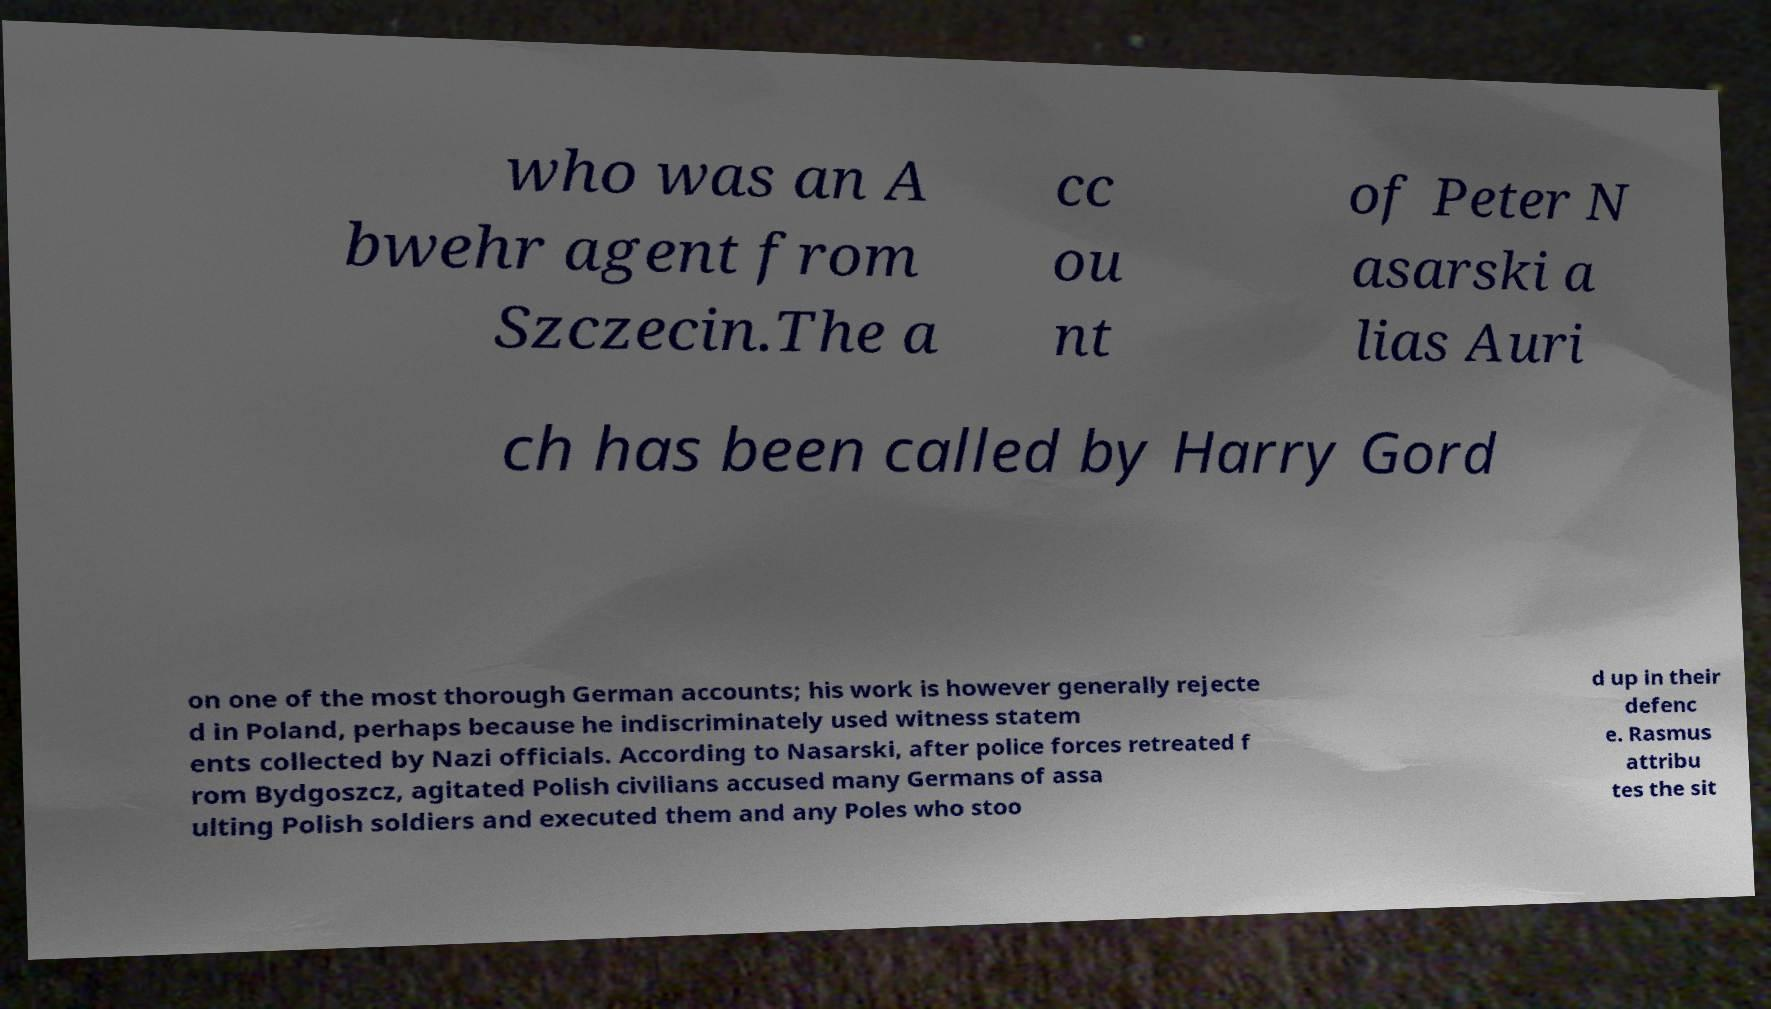For documentation purposes, I need the text within this image transcribed. Could you provide that? who was an A bwehr agent from Szczecin.The a cc ou nt of Peter N asarski a lias Auri ch has been called by Harry Gord on one of the most thorough German accounts; his work is however generally rejecte d in Poland, perhaps because he indiscriminately used witness statem ents collected by Nazi officials. According to Nasarski, after police forces retreated f rom Bydgoszcz, agitated Polish civilians accused many Germans of assa ulting Polish soldiers and executed them and any Poles who stoo d up in their defenc e. Rasmus attribu tes the sit 